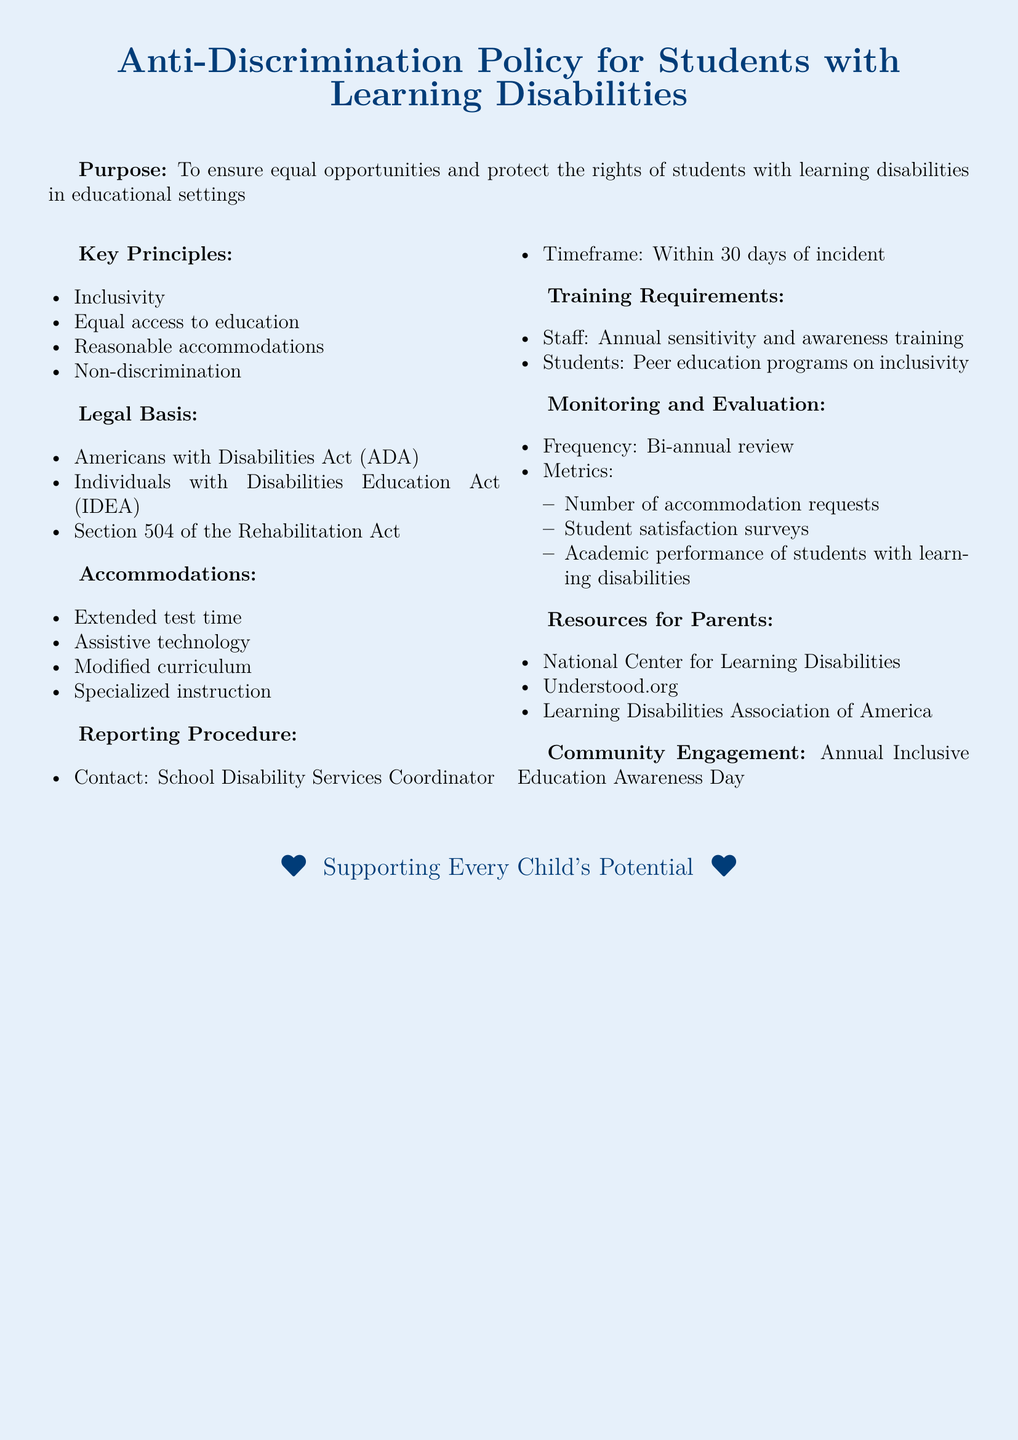What is the purpose of the policy? The purpose of the policy is to ensure equal opportunities and protect the rights of students with learning disabilities in educational settings.
Answer: To ensure equal opportunities and protect the rights of students with learning disabilities in educational settings What legal act ensures the rights of students with disabilities? The legal basis for the policy includes multiple acts, but specifically, the Americans with Disabilities Act (ADA) is one of them.
Answer: Americans with Disabilities Act (ADA) What is one type of accommodation mentioned? The document lists several accommodations, and one example is extended test time.
Answer: Extended test time Who should be contacted to report an incident? The reporting procedure indicates that the School Disability Services Coordinator should be contacted in case of an incident.
Answer: School Disability Services Coordinator How often should the monitoring and evaluation occur? The document states that monitoring and evaluation should be reviewed bi-annually.
Answer: Bi-annual What type of training do staff members need to complete? Staff members are required to complete annual sensitivity and awareness training.
Answer: Annual sensitivity and awareness training What resources are available for parents? The document lists resources, with the National Center for Learning Disabilities being one of them.
Answer: National Center for Learning Disabilities What is one way the community is engaged? The policy promotes community engagement through an Annual Inclusive Education Awareness Day.
Answer: Annual Inclusive Education Awareness Day 